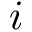<formula> <loc_0><loc_0><loc_500><loc_500>i</formula> 